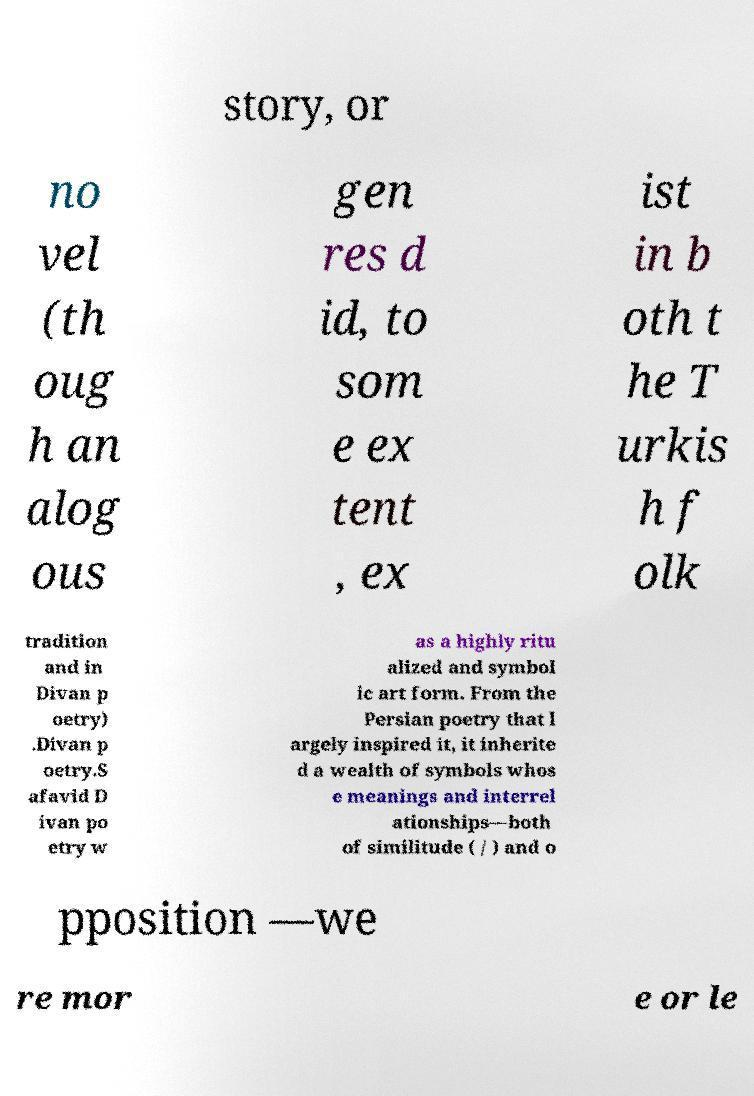For documentation purposes, I need the text within this image transcribed. Could you provide that? story, or no vel (th oug h an alog ous gen res d id, to som e ex tent , ex ist in b oth t he T urkis h f olk tradition and in Divan p oetry) .Divan p oetry.S afavid D ivan po etry w as a highly ritu alized and symbol ic art form. From the Persian poetry that l argely inspired it, it inherite d a wealth of symbols whos e meanings and interrel ationships—both of similitude ( / ) and o pposition —we re mor e or le 